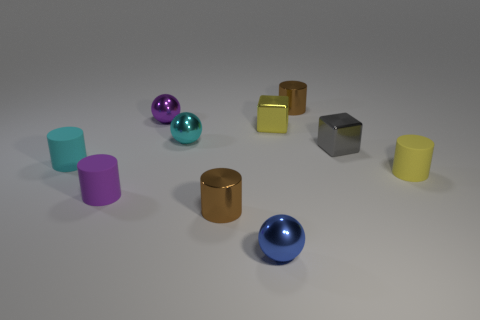How many rubber objects are behind the yellow thing that is to the right of the yellow object to the left of the tiny gray block?
Your answer should be very brief. 1. What is the small brown thing in front of the small brown cylinder behind the purple matte thing that is left of the cyan metallic thing made of?
Provide a succinct answer. Metal. Is the material of the yellow thing behind the tiny gray metallic cube the same as the blue object?
Your answer should be compact. Yes. What number of purple rubber cubes have the same size as the blue metal ball?
Ensure brevity in your answer.  0. Is the number of tiny purple things behind the cyan metallic thing greater than the number of yellow blocks on the right side of the yellow cylinder?
Your answer should be very brief. Yes. Is there a purple matte object that has the same shape as the blue thing?
Offer a very short reply. No. There is a purple rubber thing behind the sphere that is in front of the yellow rubber cylinder; what size is it?
Provide a short and direct response. Small. The tiny brown shiny object on the left side of the small brown metal cylinder behind the small matte cylinder to the right of the tiny cyan shiny thing is what shape?
Offer a terse response. Cylinder. Is the number of yellow rubber cylinders greater than the number of green cylinders?
Offer a terse response. Yes. What is the material of the cyan cylinder that is the same size as the yellow matte object?
Ensure brevity in your answer.  Rubber. 